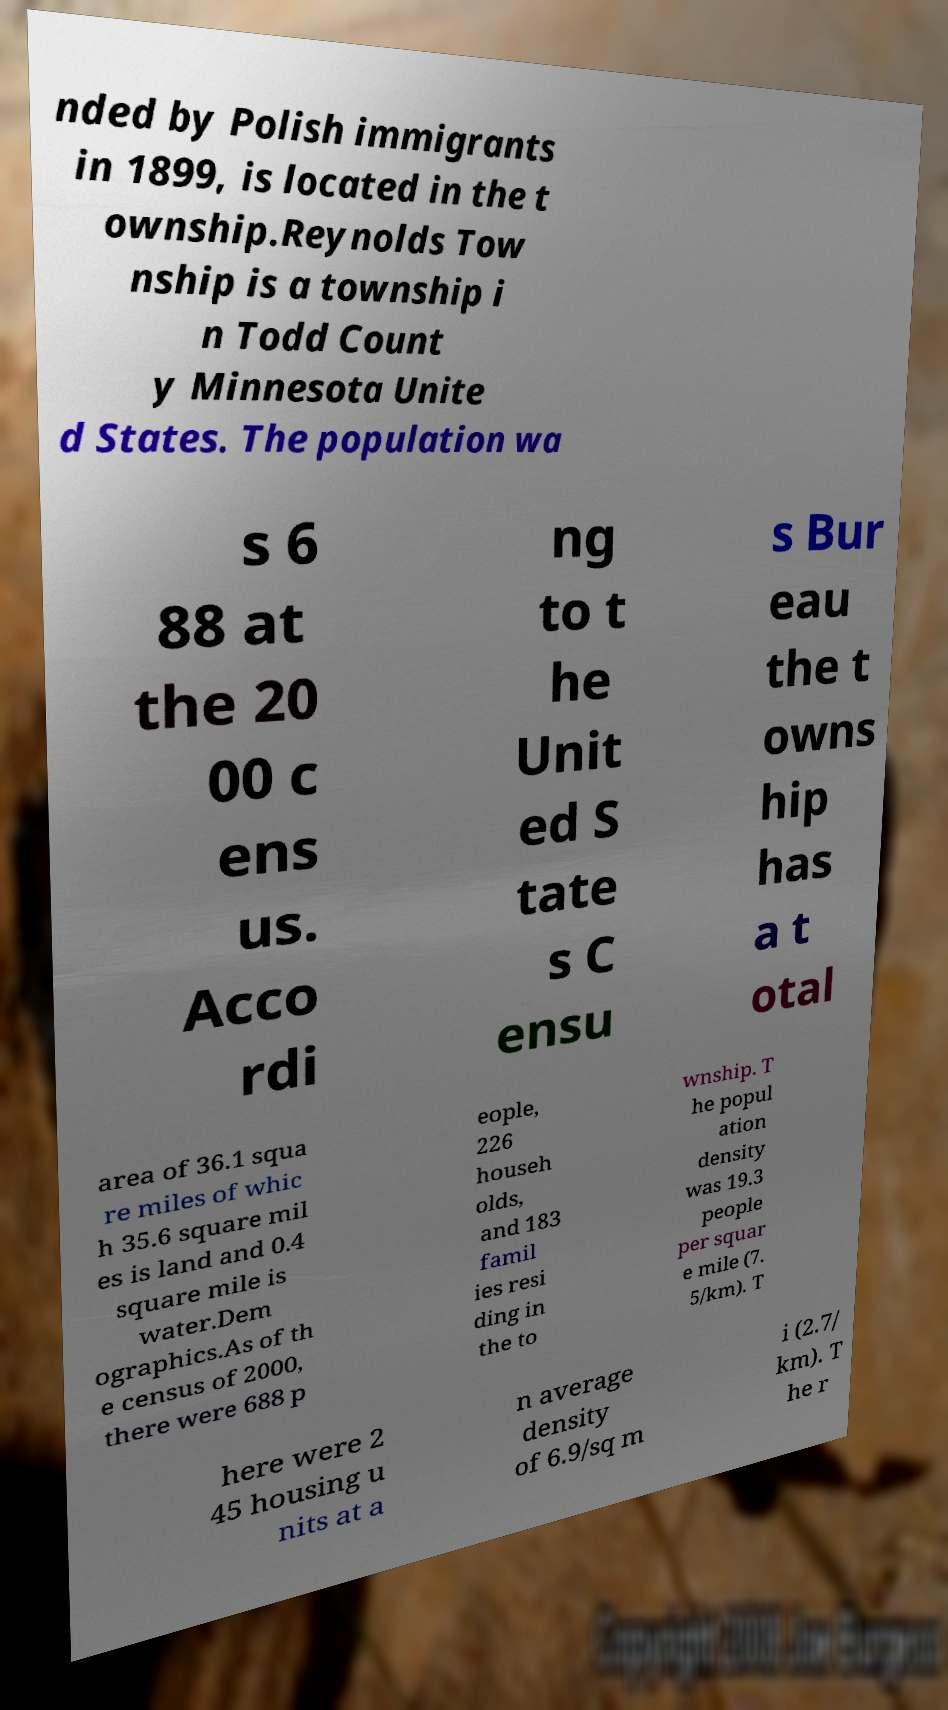Please read and relay the text visible in this image. What does it say? nded by Polish immigrants in 1899, is located in the t ownship.Reynolds Tow nship is a township i n Todd Count y Minnesota Unite d States. The population wa s 6 88 at the 20 00 c ens us. Acco rdi ng to t he Unit ed S tate s C ensu s Bur eau the t owns hip has a t otal area of 36.1 squa re miles of whic h 35.6 square mil es is land and 0.4 square mile is water.Dem ographics.As of th e census of 2000, there were 688 p eople, 226 househ olds, and 183 famil ies resi ding in the to wnship. T he popul ation density was 19.3 people per squar e mile (7. 5/km). T here were 2 45 housing u nits at a n average density of 6.9/sq m i (2.7/ km). T he r 